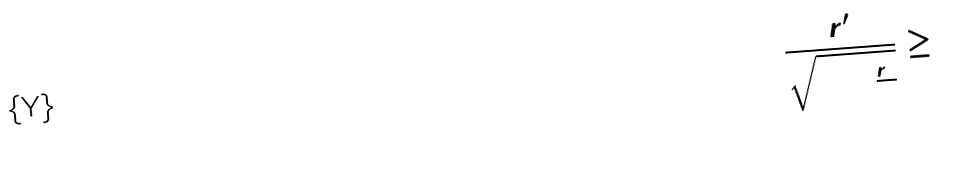<formula> <loc_0><loc_0><loc_500><loc_500>\frac { r ^ { \prime } } { \sqrt { 0 + \frac { r ^ { 2 } } { 9 } } } \geq 0</formula> 